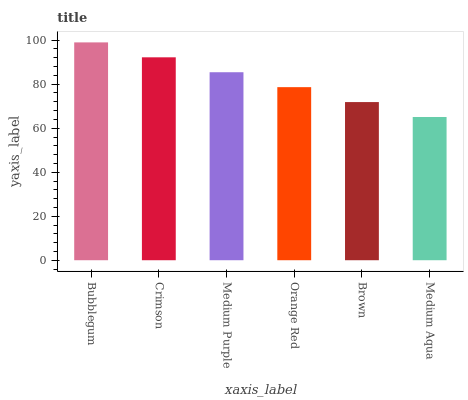Is Medium Aqua the minimum?
Answer yes or no. Yes. Is Bubblegum the maximum?
Answer yes or no. Yes. Is Crimson the minimum?
Answer yes or no. No. Is Crimson the maximum?
Answer yes or no. No. Is Bubblegum greater than Crimson?
Answer yes or no. Yes. Is Crimson less than Bubblegum?
Answer yes or no. Yes. Is Crimson greater than Bubblegum?
Answer yes or no. No. Is Bubblegum less than Crimson?
Answer yes or no. No. Is Medium Purple the high median?
Answer yes or no. Yes. Is Orange Red the low median?
Answer yes or no. Yes. Is Orange Red the high median?
Answer yes or no. No. Is Brown the low median?
Answer yes or no. No. 